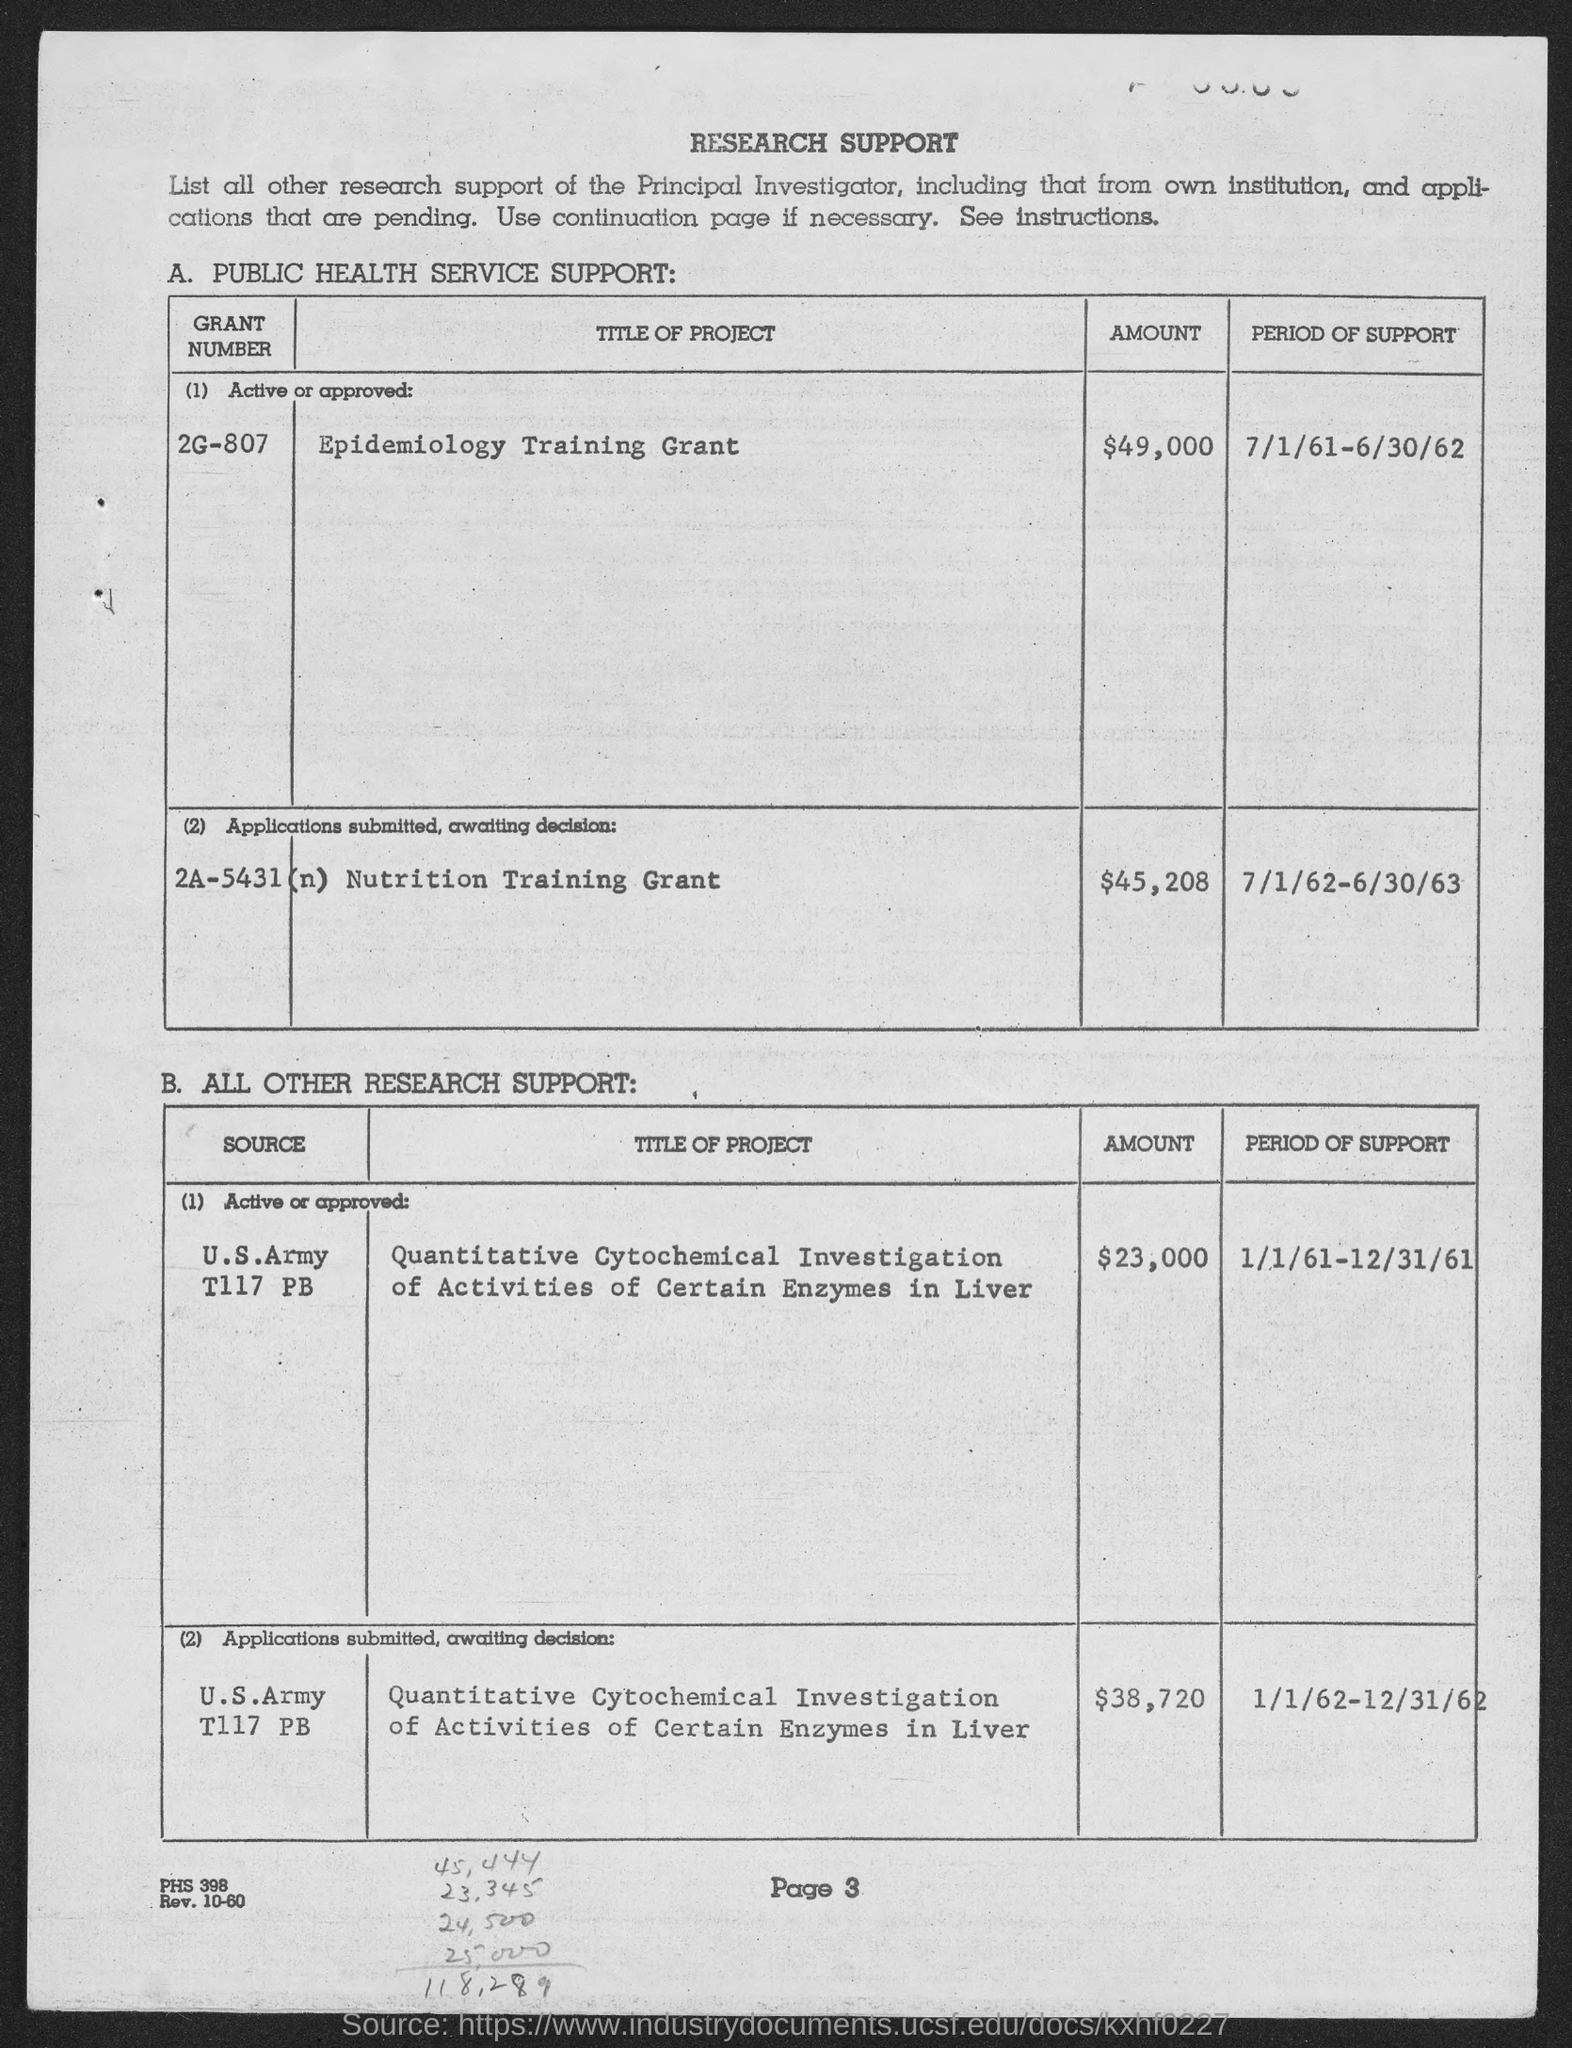Indicate a few pertinent items in this graphic. The amount of the grant for grant number 2A-5431 (n) is $45,208. This document serves as research support for...[add content here]. The page number on which the document is mentioned is page 3. The period of support for grant number 2A-5431 (n) is from July 1, 1962 to June 30, 1963. The grant number 2G-807 was supported from July 1, 1961, to June 30, 1962. 